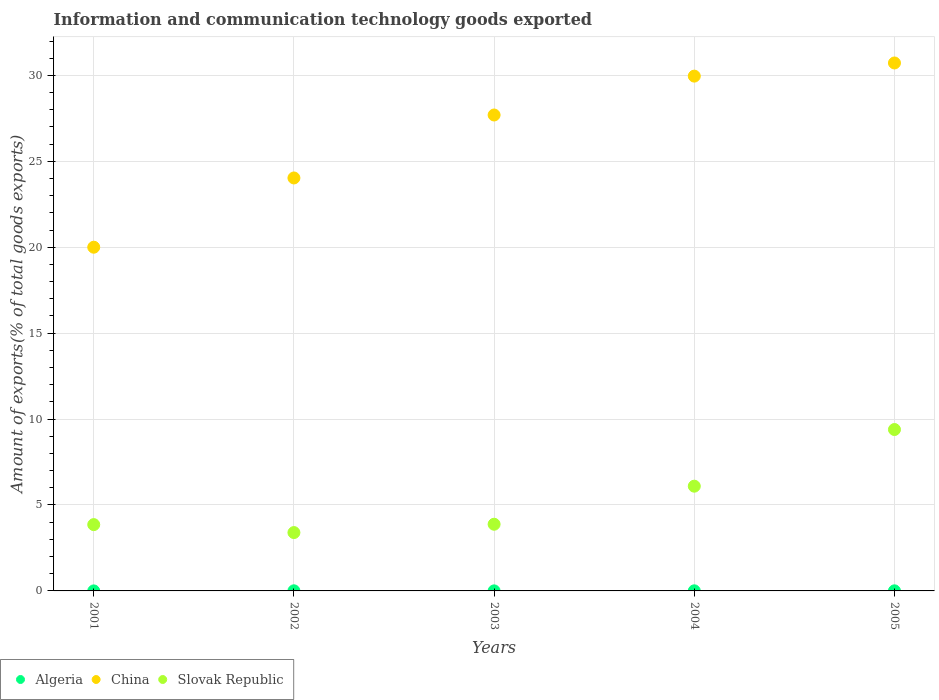How many different coloured dotlines are there?
Ensure brevity in your answer.  3. Is the number of dotlines equal to the number of legend labels?
Keep it short and to the point. Yes. What is the amount of goods exported in China in 2003?
Keep it short and to the point. 27.69. Across all years, what is the maximum amount of goods exported in Algeria?
Make the answer very short. 0.01. Across all years, what is the minimum amount of goods exported in Slovak Republic?
Give a very brief answer. 3.4. In which year was the amount of goods exported in Slovak Republic minimum?
Provide a succinct answer. 2002. What is the total amount of goods exported in Algeria in the graph?
Provide a succinct answer. 0.02. What is the difference between the amount of goods exported in Algeria in 2001 and that in 2003?
Offer a terse response. -0. What is the difference between the amount of goods exported in Slovak Republic in 2003 and the amount of goods exported in China in 2001?
Provide a succinct answer. -16.12. What is the average amount of goods exported in Algeria per year?
Provide a short and direct response. 0. In the year 2001, what is the difference between the amount of goods exported in Slovak Republic and amount of goods exported in China?
Your answer should be compact. -16.14. In how many years, is the amount of goods exported in China greater than 13 %?
Offer a terse response. 5. What is the ratio of the amount of goods exported in Algeria in 2001 to that in 2003?
Make the answer very short. 0.41. Is the amount of goods exported in Slovak Republic in 2004 less than that in 2005?
Make the answer very short. Yes. What is the difference between the highest and the second highest amount of goods exported in China?
Provide a short and direct response. 0.76. What is the difference between the highest and the lowest amount of goods exported in China?
Your answer should be compact. 10.72. Is the sum of the amount of goods exported in Slovak Republic in 2001 and 2004 greater than the maximum amount of goods exported in China across all years?
Your answer should be compact. No. Is it the case that in every year, the sum of the amount of goods exported in Algeria and amount of goods exported in China  is greater than the amount of goods exported in Slovak Republic?
Make the answer very short. Yes. Does the amount of goods exported in Algeria monotonically increase over the years?
Offer a very short reply. No. How many dotlines are there?
Make the answer very short. 3. How many years are there in the graph?
Give a very brief answer. 5. What is the difference between two consecutive major ticks on the Y-axis?
Give a very brief answer. 5. Are the values on the major ticks of Y-axis written in scientific E-notation?
Provide a short and direct response. No. Does the graph contain any zero values?
Offer a very short reply. No. Does the graph contain grids?
Ensure brevity in your answer.  Yes. Where does the legend appear in the graph?
Provide a short and direct response. Bottom left. What is the title of the graph?
Your answer should be very brief. Information and communication technology goods exported. What is the label or title of the X-axis?
Provide a succinct answer. Years. What is the label or title of the Y-axis?
Offer a terse response. Amount of exports(% of total goods exports). What is the Amount of exports(% of total goods exports) of Algeria in 2001?
Keep it short and to the point. 0. What is the Amount of exports(% of total goods exports) in China in 2001?
Give a very brief answer. 20. What is the Amount of exports(% of total goods exports) in Slovak Republic in 2001?
Your answer should be compact. 3.86. What is the Amount of exports(% of total goods exports) of Algeria in 2002?
Offer a very short reply. 0.01. What is the Amount of exports(% of total goods exports) in China in 2002?
Keep it short and to the point. 24.03. What is the Amount of exports(% of total goods exports) of Slovak Republic in 2002?
Ensure brevity in your answer.  3.4. What is the Amount of exports(% of total goods exports) of Algeria in 2003?
Give a very brief answer. 0. What is the Amount of exports(% of total goods exports) in China in 2003?
Give a very brief answer. 27.69. What is the Amount of exports(% of total goods exports) of Slovak Republic in 2003?
Ensure brevity in your answer.  3.88. What is the Amount of exports(% of total goods exports) in Algeria in 2004?
Your answer should be very brief. 0.01. What is the Amount of exports(% of total goods exports) of China in 2004?
Ensure brevity in your answer.  29.96. What is the Amount of exports(% of total goods exports) of Slovak Republic in 2004?
Give a very brief answer. 6.09. What is the Amount of exports(% of total goods exports) in Algeria in 2005?
Provide a short and direct response. 0.01. What is the Amount of exports(% of total goods exports) of China in 2005?
Ensure brevity in your answer.  30.72. What is the Amount of exports(% of total goods exports) of Slovak Republic in 2005?
Offer a very short reply. 9.39. Across all years, what is the maximum Amount of exports(% of total goods exports) of Algeria?
Provide a short and direct response. 0.01. Across all years, what is the maximum Amount of exports(% of total goods exports) in China?
Your answer should be very brief. 30.72. Across all years, what is the maximum Amount of exports(% of total goods exports) of Slovak Republic?
Your answer should be compact. 9.39. Across all years, what is the minimum Amount of exports(% of total goods exports) in Algeria?
Your answer should be compact. 0. Across all years, what is the minimum Amount of exports(% of total goods exports) of China?
Keep it short and to the point. 20. Across all years, what is the minimum Amount of exports(% of total goods exports) in Slovak Republic?
Offer a terse response. 3.4. What is the total Amount of exports(% of total goods exports) of Algeria in the graph?
Keep it short and to the point. 0.02. What is the total Amount of exports(% of total goods exports) in China in the graph?
Ensure brevity in your answer.  132.4. What is the total Amount of exports(% of total goods exports) in Slovak Republic in the graph?
Your answer should be compact. 26.62. What is the difference between the Amount of exports(% of total goods exports) of Algeria in 2001 and that in 2002?
Give a very brief answer. -0.01. What is the difference between the Amount of exports(% of total goods exports) of China in 2001 and that in 2002?
Your answer should be very brief. -4.03. What is the difference between the Amount of exports(% of total goods exports) in Slovak Republic in 2001 and that in 2002?
Your answer should be very brief. 0.46. What is the difference between the Amount of exports(% of total goods exports) in Algeria in 2001 and that in 2003?
Provide a short and direct response. -0. What is the difference between the Amount of exports(% of total goods exports) in China in 2001 and that in 2003?
Make the answer very short. -7.69. What is the difference between the Amount of exports(% of total goods exports) of Slovak Republic in 2001 and that in 2003?
Your response must be concise. -0.02. What is the difference between the Amount of exports(% of total goods exports) of Algeria in 2001 and that in 2004?
Your answer should be compact. -0. What is the difference between the Amount of exports(% of total goods exports) in China in 2001 and that in 2004?
Provide a succinct answer. -9.96. What is the difference between the Amount of exports(% of total goods exports) in Slovak Republic in 2001 and that in 2004?
Ensure brevity in your answer.  -2.24. What is the difference between the Amount of exports(% of total goods exports) of Algeria in 2001 and that in 2005?
Offer a terse response. -0. What is the difference between the Amount of exports(% of total goods exports) of China in 2001 and that in 2005?
Make the answer very short. -10.72. What is the difference between the Amount of exports(% of total goods exports) in Slovak Republic in 2001 and that in 2005?
Ensure brevity in your answer.  -5.53. What is the difference between the Amount of exports(% of total goods exports) of Algeria in 2002 and that in 2003?
Your answer should be compact. 0. What is the difference between the Amount of exports(% of total goods exports) in China in 2002 and that in 2003?
Provide a succinct answer. -3.66. What is the difference between the Amount of exports(% of total goods exports) in Slovak Republic in 2002 and that in 2003?
Your response must be concise. -0.48. What is the difference between the Amount of exports(% of total goods exports) of Algeria in 2002 and that in 2004?
Provide a short and direct response. 0. What is the difference between the Amount of exports(% of total goods exports) of China in 2002 and that in 2004?
Your response must be concise. -5.93. What is the difference between the Amount of exports(% of total goods exports) of Slovak Republic in 2002 and that in 2004?
Offer a terse response. -2.7. What is the difference between the Amount of exports(% of total goods exports) of Algeria in 2002 and that in 2005?
Provide a succinct answer. 0. What is the difference between the Amount of exports(% of total goods exports) in China in 2002 and that in 2005?
Your answer should be compact. -6.69. What is the difference between the Amount of exports(% of total goods exports) in Slovak Republic in 2002 and that in 2005?
Ensure brevity in your answer.  -6. What is the difference between the Amount of exports(% of total goods exports) of Algeria in 2003 and that in 2004?
Provide a short and direct response. -0. What is the difference between the Amount of exports(% of total goods exports) of China in 2003 and that in 2004?
Provide a short and direct response. -2.26. What is the difference between the Amount of exports(% of total goods exports) in Slovak Republic in 2003 and that in 2004?
Your answer should be compact. -2.21. What is the difference between the Amount of exports(% of total goods exports) of Algeria in 2003 and that in 2005?
Provide a succinct answer. -0. What is the difference between the Amount of exports(% of total goods exports) of China in 2003 and that in 2005?
Your answer should be compact. -3.03. What is the difference between the Amount of exports(% of total goods exports) in Slovak Republic in 2003 and that in 2005?
Keep it short and to the point. -5.51. What is the difference between the Amount of exports(% of total goods exports) in Algeria in 2004 and that in 2005?
Give a very brief answer. 0. What is the difference between the Amount of exports(% of total goods exports) in China in 2004 and that in 2005?
Offer a terse response. -0.76. What is the difference between the Amount of exports(% of total goods exports) in Slovak Republic in 2004 and that in 2005?
Your answer should be compact. -3.3. What is the difference between the Amount of exports(% of total goods exports) of Algeria in 2001 and the Amount of exports(% of total goods exports) of China in 2002?
Make the answer very short. -24.03. What is the difference between the Amount of exports(% of total goods exports) of Algeria in 2001 and the Amount of exports(% of total goods exports) of Slovak Republic in 2002?
Provide a succinct answer. -3.39. What is the difference between the Amount of exports(% of total goods exports) of China in 2001 and the Amount of exports(% of total goods exports) of Slovak Republic in 2002?
Your response must be concise. 16.61. What is the difference between the Amount of exports(% of total goods exports) in Algeria in 2001 and the Amount of exports(% of total goods exports) in China in 2003?
Your answer should be compact. -27.69. What is the difference between the Amount of exports(% of total goods exports) in Algeria in 2001 and the Amount of exports(% of total goods exports) in Slovak Republic in 2003?
Your answer should be very brief. -3.88. What is the difference between the Amount of exports(% of total goods exports) of China in 2001 and the Amount of exports(% of total goods exports) of Slovak Republic in 2003?
Provide a short and direct response. 16.12. What is the difference between the Amount of exports(% of total goods exports) of Algeria in 2001 and the Amount of exports(% of total goods exports) of China in 2004?
Your answer should be very brief. -29.96. What is the difference between the Amount of exports(% of total goods exports) in Algeria in 2001 and the Amount of exports(% of total goods exports) in Slovak Republic in 2004?
Your answer should be very brief. -6.09. What is the difference between the Amount of exports(% of total goods exports) of China in 2001 and the Amount of exports(% of total goods exports) of Slovak Republic in 2004?
Offer a very short reply. 13.91. What is the difference between the Amount of exports(% of total goods exports) of Algeria in 2001 and the Amount of exports(% of total goods exports) of China in 2005?
Provide a succinct answer. -30.72. What is the difference between the Amount of exports(% of total goods exports) in Algeria in 2001 and the Amount of exports(% of total goods exports) in Slovak Republic in 2005?
Offer a terse response. -9.39. What is the difference between the Amount of exports(% of total goods exports) of China in 2001 and the Amount of exports(% of total goods exports) of Slovak Republic in 2005?
Your answer should be very brief. 10.61. What is the difference between the Amount of exports(% of total goods exports) of Algeria in 2002 and the Amount of exports(% of total goods exports) of China in 2003?
Keep it short and to the point. -27.69. What is the difference between the Amount of exports(% of total goods exports) in Algeria in 2002 and the Amount of exports(% of total goods exports) in Slovak Republic in 2003?
Offer a very short reply. -3.87. What is the difference between the Amount of exports(% of total goods exports) of China in 2002 and the Amount of exports(% of total goods exports) of Slovak Republic in 2003?
Give a very brief answer. 20.15. What is the difference between the Amount of exports(% of total goods exports) in Algeria in 2002 and the Amount of exports(% of total goods exports) in China in 2004?
Provide a succinct answer. -29.95. What is the difference between the Amount of exports(% of total goods exports) of Algeria in 2002 and the Amount of exports(% of total goods exports) of Slovak Republic in 2004?
Your answer should be very brief. -6.09. What is the difference between the Amount of exports(% of total goods exports) of China in 2002 and the Amount of exports(% of total goods exports) of Slovak Republic in 2004?
Offer a very short reply. 17.94. What is the difference between the Amount of exports(% of total goods exports) of Algeria in 2002 and the Amount of exports(% of total goods exports) of China in 2005?
Offer a very short reply. -30.71. What is the difference between the Amount of exports(% of total goods exports) of Algeria in 2002 and the Amount of exports(% of total goods exports) of Slovak Republic in 2005?
Ensure brevity in your answer.  -9.38. What is the difference between the Amount of exports(% of total goods exports) of China in 2002 and the Amount of exports(% of total goods exports) of Slovak Republic in 2005?
Give a very brief answer. 14.64. What is the difference between the Amount of exports(% of total goods exports) of Algeria in 2003 and the Amount of exports(% of total goods exports) of China in 2004?
Provide a short and direct response. -29.95. What is the difference between the Amount of exports(% of total goods exports) of Algeria in 2003 and the Amount of exports(% of total goods exports) of Slovak Republic in 2004?
Your answer should be compact. -6.09. What is the difference between the Amount of exports(% of total goods exports) of China in 2003 and the Amount of exports(% of total goods exports) of Slovak Republic in 2004?
Ensure brevity in your answer.  21.6. What is the difference between the Amount of exports(% of total goods exports) in Algeria in 2003 and the Amount of exports(% of total goods exports) in China in 2005?
Your response must be concise. -30.72. What is the difference between the Amount of exports(% of total goods exports) of Algeria in 2003 and the Amount of exports(% of total goods exports) of Slovak Republic in 2005?
Ensure brevity in your answer.  -9.39. What is the difference between the Amount of exports(% of total goods exports) of China in 2003 and the Amount of exports(% of total goods exports) of Slovak Republic in 2005?
Offer a very short reply. 18.3. What is the difference between the Amount of exports(% of total goods exports) of Algeria in 2004 and the Amount of exports(% of total goods exports) of China in 2005?
Offer a very short reply. -30.72. What is the difference between the Amount of exports(% of total goods exports) in Algeria in 2004 and the Amount of exports(% of total goods exports) in Slovak Republic in 2005?
Your response must be concise. -9.39. What is the difference between the Amount of exports(% of total goods exports) in China in 2004 and the Amount of exports(% of total goods exports) in Slovak Republic in 2005?
Provide a succinct answer. 20.57. What is the average Amount of exports(% of total goods exports) of Algeria per year?
Give a very brief answer. 0. What is the average Amount of exports(% of total goods exports) in China per year?
Ensure brevity in your answer.  26.48. What is the average Amount of exports(% of total goods exports) in Slovak Republic per year?
Offer a very short reply. 5.32. In the year 2001, what is the difference between the Amount of exports(% of total goods exports) of Algeria and Amount of exports(% of total goods exports) of China?
Your answer should be very brief. -20. In the year 2001, what is the difference between the Amount of exports(% of total goods exports) in Algeria and Amount of exports(% of total goods exports) in Slovak Republic?
Your response must be concise. -3.86. In the year 2001, what is the difference between the Amount of exports(% of total goods exports) of China and Amount of exports(% of total goods exports) of Slovak Republic?
Your response must be concise. 16.14. In the year 2002, what is the difference between the Amount of exports(% of total goods exports) in Algeria and Amount of exports(% of total goods exports) in China?
Your answer should be very brief. -24.02. In the year 2002, what is the difference between the Amount of exports(% of total goods exports) in Algeria and Amount of exports(% of total goods exports) in Slovak Republic?
Your response must be concise. -3.39. In the year 2002, what is the difference between the Amount of exports(% of total goods exports) of China and Amount of exports(% of total goods exports) of Slovak Republic?
Make the answer very short. 20.64. In the year 2003, what is the difference between the Amount of exports(% of total goods exports) of Algeria and Amount of exports(% of total goods exports) of China?
Provide a short and direct response. -27.69. In the year 2003, what is the difference between the Amount of exports(% of total goods exports) of Algeria and Amount of exports(% of total goods exports) of Slovak Republic?
Give a very brief answer. -3.88. In the year 2003, what is the difference between the Amount of exports(% of total goods exports) in China and Amount of exports(% of total goods exports) in Slovak Republic?
Your answer should be compact. 23.81. In the year 2004, what is the difference between the Amount of exports(% of total goods exports) of Algeria and Amount of exports(% of total goods exports) of China?
Your answer should be very brief. -29.95. In the year 2004, what is the difference between the Amount of exports(% of total goods exports) in Algeria and Amount of exports(% of total goods exports) in Slovak Republic?
Your response must be concise. -6.09. In the year 2004, what is the difference between the Amount of exports(% of total goods exports) of China and Amount of exports(% of total goods exports) of Slovak Republic?
Offer a very short reply. 23.86. In the year 2005, what is the difference between the Amount of exports(% of total goods exports) of Algeria and Amount of exports(% of total goods exports) of China?
Keep it short and to the point. -30.72. In the year 2005, what is the difference between the Amount of exports(% of total goods exports) in Algeria and Amount of exports(% of total goods exports) in Slovak Republic?
Provide a short and direct response. -9.39. In the year 2005, what is the difference between the Amount of exports(% of total goods exports) of China and Amount of exports(% of total goods exports) of Slovak Republic?
Your answer should be compact. 21.33. What is the ratio of the Amount of exports(% of total goods exports) of Algeria in 2001 to that in 2002?
Offer a very short reply. 0.17. What is the ratio of the Amount of exports(% of total goods exports) in China in 2001 to that in 2002?
Make the answer very short. 0.83. What is the ratio of the Amount of exports(% of total goods exports) in Slovak Republic in 2001 to that in 2002?
Make the answer very short. 1.14. What is the ratio of the Amount of exports(% of total goods exports) in Algeria in 2001 to that in 2003?
Provide a short and direct response. 0.41. What is the ratio of the Amount of exports(% of total goods exports) of China in 2001 to that in 2003?
Provide a succinct answer. 0.72. What is the ratio of the Amount of exports(% of total goods exports) of Slovak Republic in 2001 to that in 2003?
Ensure brevity in your answer.  0.99. What is the ratio of the Amount of exports(% of total goods exports) of Algeria in 2001 to that in 2004?
Your answer should be very brief. 0.2. What is the ratio of the Amount of exports(% of total goods exports) in China in 2001 to that in 2004?
Give a very brief answer. 0.67. What is the ratio of the Amount of exports(% of total goods exports) in Slovak Republic in 2001 to that in 2004?
Make the answer very short. 0.63. What is the ratio of the Amount of exports(% of total goods exports) in Algeria in 2001 to that in 2005?
Provide a succinct answer. 0.21. What is the ratio of the Amount of exports(% of total goods exports) of China in 2001 to that in 2005?
Provide a short and direct response. 0.65. What is the ratio of the Amount of exports(% of total goods exports) of Slovak Republic in 2001 to that in 2005?
Provide a succinct answer. 0.41. What is the ratio of the Amount of exports(% of total goods exports) of Algeria in 2002 to that in 2003?
Provide a succinct answer. 2.45. What is the ratio of the Amount of exports(% of total goods exports) in China in 2002 to that in 2003?
Make the answer very short. 0.87. What is the ratio of the Amount of exports(% of total goods exports) in Slovak Republic in 2002 to that in 2003?
Provide a succinct answer. 0.88. What is the ratio of the Amount of exports(% of total goods exports) of Algeria in 2002 to that in 2004?
Your response must be concise. 1.18. What is the ratio of the Amount of exports(% of total goods exports) of China in 2002 to that in 2004?
Make the answer very short. 0.8. What is the ratio of the Amount of exports(% of total goods exports) of Slovak Republic in 2002 to that in 2004?
Your answer should be compact. 0.56. What is the ratio of the Amount of exports(% of total goods exports) in Algeria in 2002 to that in 2005?
Ensure brevity in your answer.  1.27. What is the ratio of the Amount of exports(% of total goods exports) of China in 2002 to that in 2005?
Keep it short and to the point. 0.78. What is the ratio of the Amount of exports(% of total goods exports) in Slovak Republic in 2002 to that in 2005?
Offer a terse response. 0.36. What is the ratio of the Amount of exports(% of total goods exports) of Algeria in 2003 to that in 2004?
Your answer should be very brief. 0.48. What is the ratio of the Amount of exports(% of total goods exports) in China in 2003 to that in 2004?
Make the answer very short. 0.92. What is the ratio of the Amount of exports(% of total goods exports) in Slovak Republic in 2003 to that in 2004?
Your response must be concise. 0.64. What is the ratio of the Amount of exports(% of total goods exports) of Algeria in 2003 to that in 2005?
Offer a terse response. 0.52. What is the ratio of the Amount of exports(% of total goods exports) of China in 2003 to that in 2005?
Keep it short and to the point. 0.9. What is the ratio of the Amount of exports(% of total goods exports) in Slovak Republic in 2003 to that in 2005?
Provide a succinct answer. 0.41. What is the ratio of the Amount of exports(% of total goods exports) in Algeria in 2004 to that in 2005?
Provide a short and direct response. 1.07. What is the ratio of the Amount of exports(% of total goods exports) of China in 2004 to that in 2005?
Keep it short and to the point. 0.98. What is the ratio of the Amount of exports(% of total goods exports) in Slovak Republic in 2004 to that in 2005?
Offer a very short reply. 0.65. What is the difference between the highest and the second highest Amount of exports(% of total goods exports) of Algeria?
Offer a very short reply. 0. What is the difference between the highest and the second highest Amount of exports(% of total goods exports) in China?
Your answer should be compact. 0.76. What is the difference between the highest and the second highest Amount of exports(% of total goods exports) in Slovak Republic?
Provide a succinct answer. 3.3. What is the difference between the highest and the lowest Amount of exports(% of total goods exports) of Algeria?
Your answer should be compact. 0.01. What is the difference between the highest and the lowest Amount of exports(% of total goods exports) of China?
Make the answer very short. 10.72. What is the difference between the highest and the lowest Amount of exports(% of total goods exports) in Slovak Republic?
Offer a terse response. 6. 